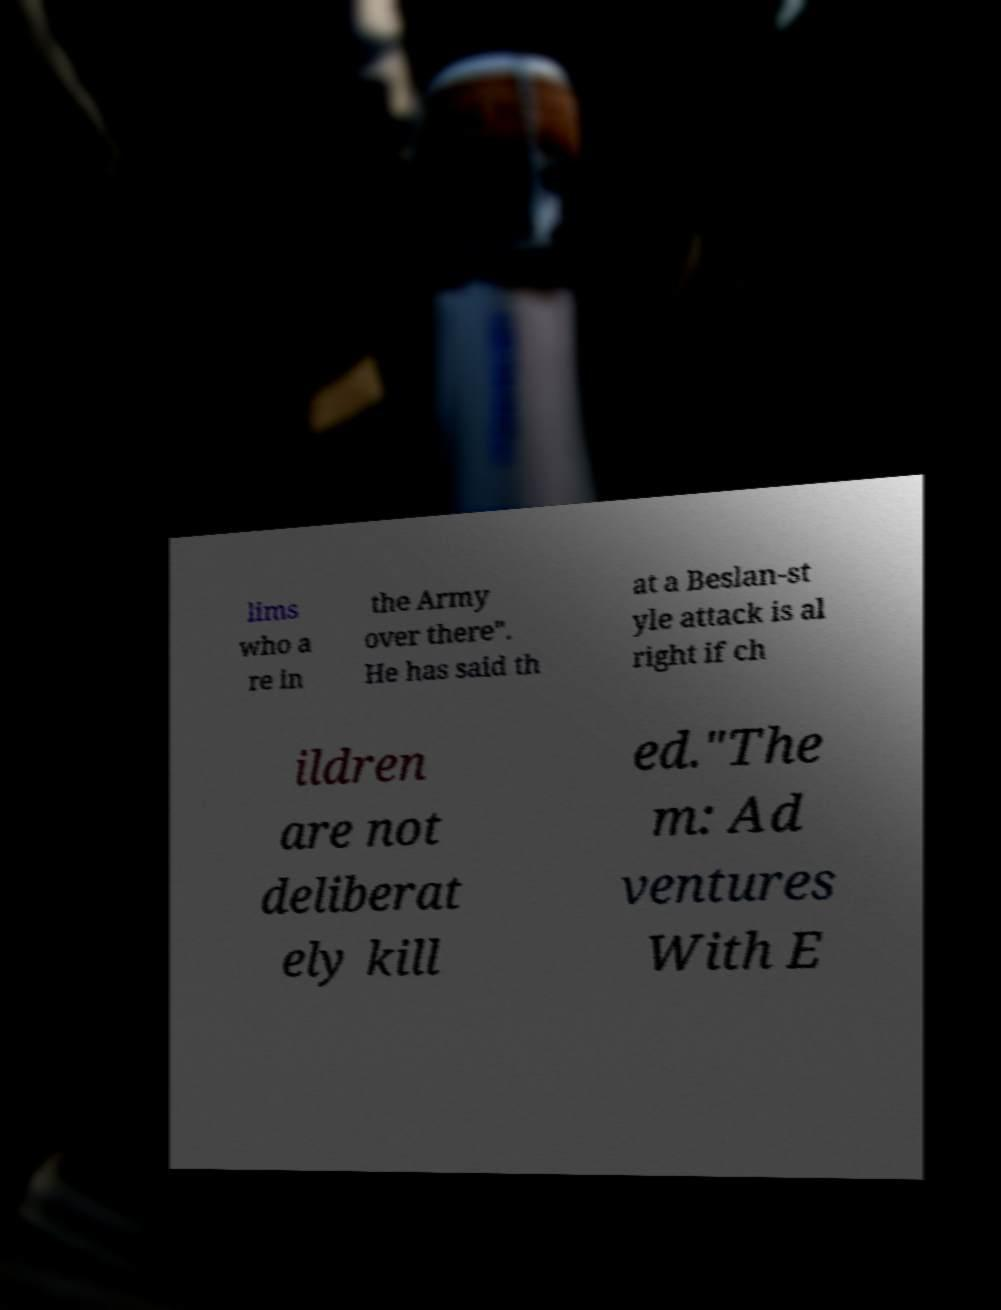I need the written content from this picture converted into text. Can you do that? lims who a re in the Army over there". He has said th at a Beslan-st yle attack is al right if ch ildren are not deliberat ely kill ed."The m: Ad ventures With E 